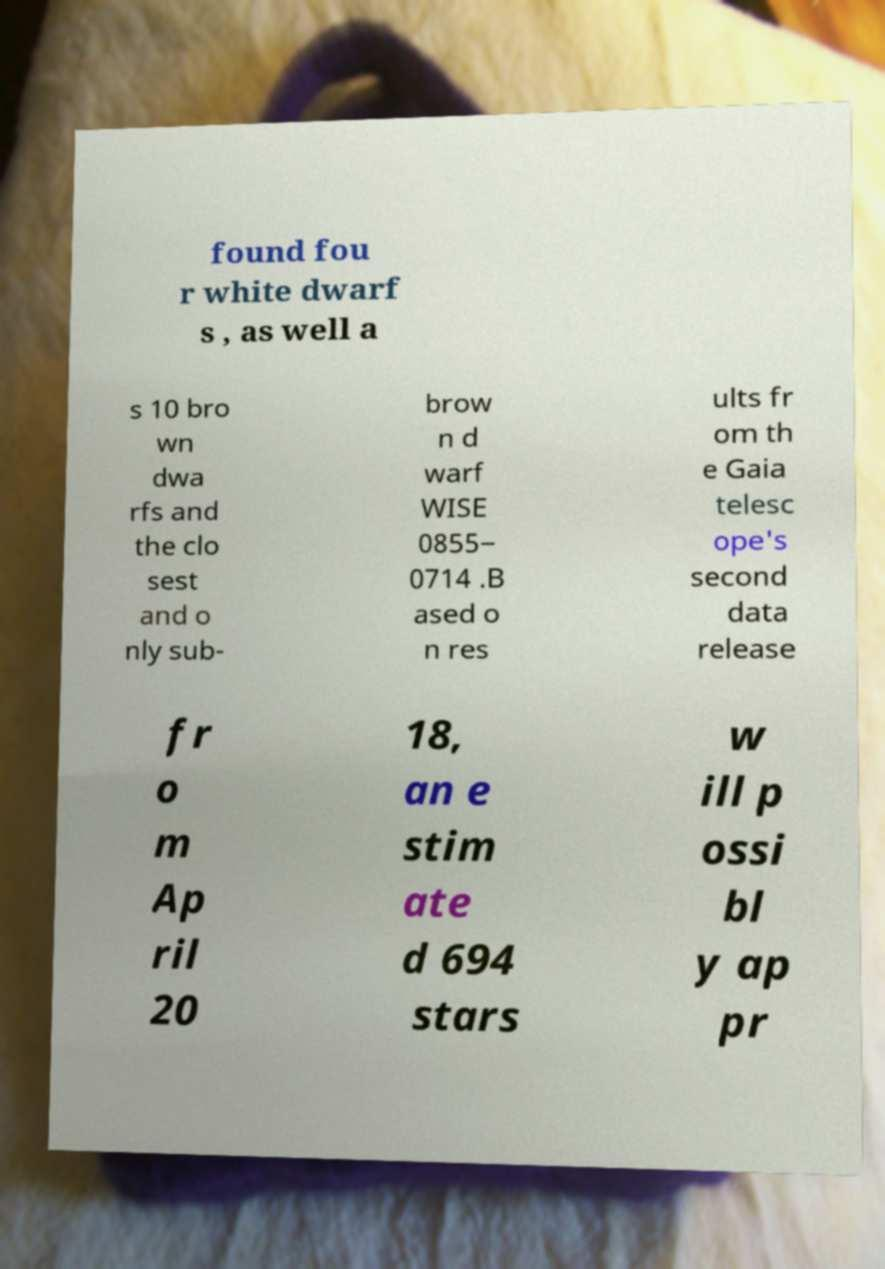For documentation purposes, I need the text within this image transcribed. Could you provide that? found fou r white dwarf s , as well a s 10 bro wn dwa rfs and the clo sest and o nly sub- brow n d warf WISE 0855− 0714 .B ased o n res ults fr om th e Gaia telesc ope's second data release fr o m Ap ril 20 18, an e stim ate d 694 stars w ill p ossi bl y ap pr 